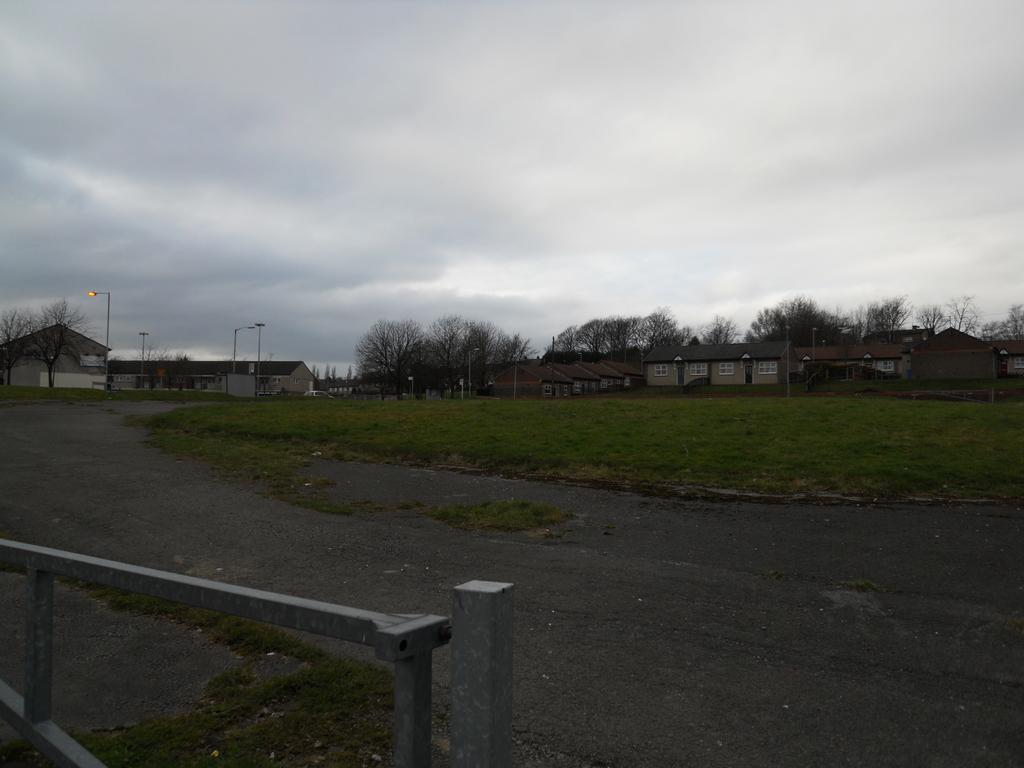Please provide a concise description of this image. In the image we can see there is a road and there is ground covered with grass. There are street light poles and there are lot of trees. Behind there are buildings and there is a cloudy sky. 